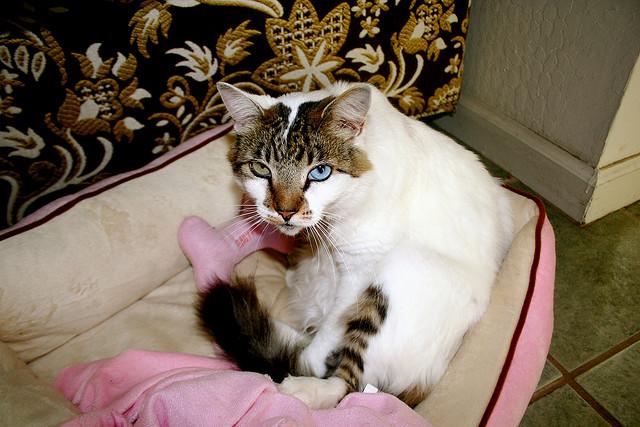Is the cat sitting on the laptop?
Give a very brief answer. No. Does the cat look happy?
Short answer required. No. What kind of cat is pictured?
Be succinct. Tabby. Is the floor multi-colored?
Quick response, please. No. What color are the cats eyes?
Write a very short answer. Blue and green. Does this animal belong here?
Give a very brief answer. Yes. Is the cat an inside cat?
Write a very short answer. Yes. Is the cat angry?
Quick response, please. No. What shape is the cat bed?
Be succinct. Rectangular. What color are the tiles on the floor?
Answer briefly. Green. 